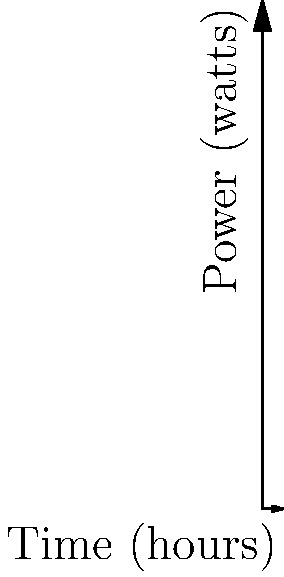A trailerable sailboat is equipped with three main electrical systems: navigation, lighting, and refrigeration. The power consumption of each system over a 12-hour period is shown in the graph above. Calculate the total energy consumption in watt-hours for all three systems combined over the entire 12-hour period. Assume the power consumption between data points follows a sinusoidal pattern as shown. To solve this problem, we need to calculate the area under each curve and sum them up. Since the curves are sinusoidal, we can use integration to find the exact area.

1. For the navigation system:
   $P_1(t) = 50 + 10\sin(\frac{\pi t}{6})$ watts
   Energy = $\int_0^{12} (50 + 10\sin(\frac{\pi t}{6})) dt$
   = $[50t - \frac{60}{\pi}\cos(\frac{\pi t}{6})]_0^{12}$
   = $600 - \frac{60}{\pi}(\cos(2\pi) - 1)$ = 600 watt-hours

2. For the lighting system:
   $P_2(t) = 100 + 20\sin(\frac{\pi t}{4})$ watts
   Energy = $\int_0^{12} (100 + 20\sin(\frac{\pi t}{4})) dt$
   = $[100t - \frac{80}{\pi}\cos(\frac{\pi t}{4})]_0^{12}$
   = $1200 - \frac{80}{\pi}(\cos(3\pi) - 1)$ = 1200 watt-hours

3. For the refrigeration system:
   $P_3(t) = 150 + 30\sin(\frac{\pi t}{3})$ watts
   Energy = $\int_0^{12} (150 + 30\sin(\frac{\pi t}{3})) dt$
   = $[150t - \frac{90}{\pi}\cos(\frac{\pi t}{3})]_0^{12}$
   = $1800 - \frac{90}{\pi}(\cos(4\pi) - 1)$ = 1800 watt-hours

4. Total energy consumption:
   600 + 1200 + 1800 = 3600 watt-hours
Answer: 3600 watt-hours 